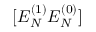Convert formula to latex. <formula><loc_0><loc_0><loc_500><loc_500>[ E _ { N } ^ { ( 1 ) } E _ { N } ^ { ( 0 ) } ]</formula> 